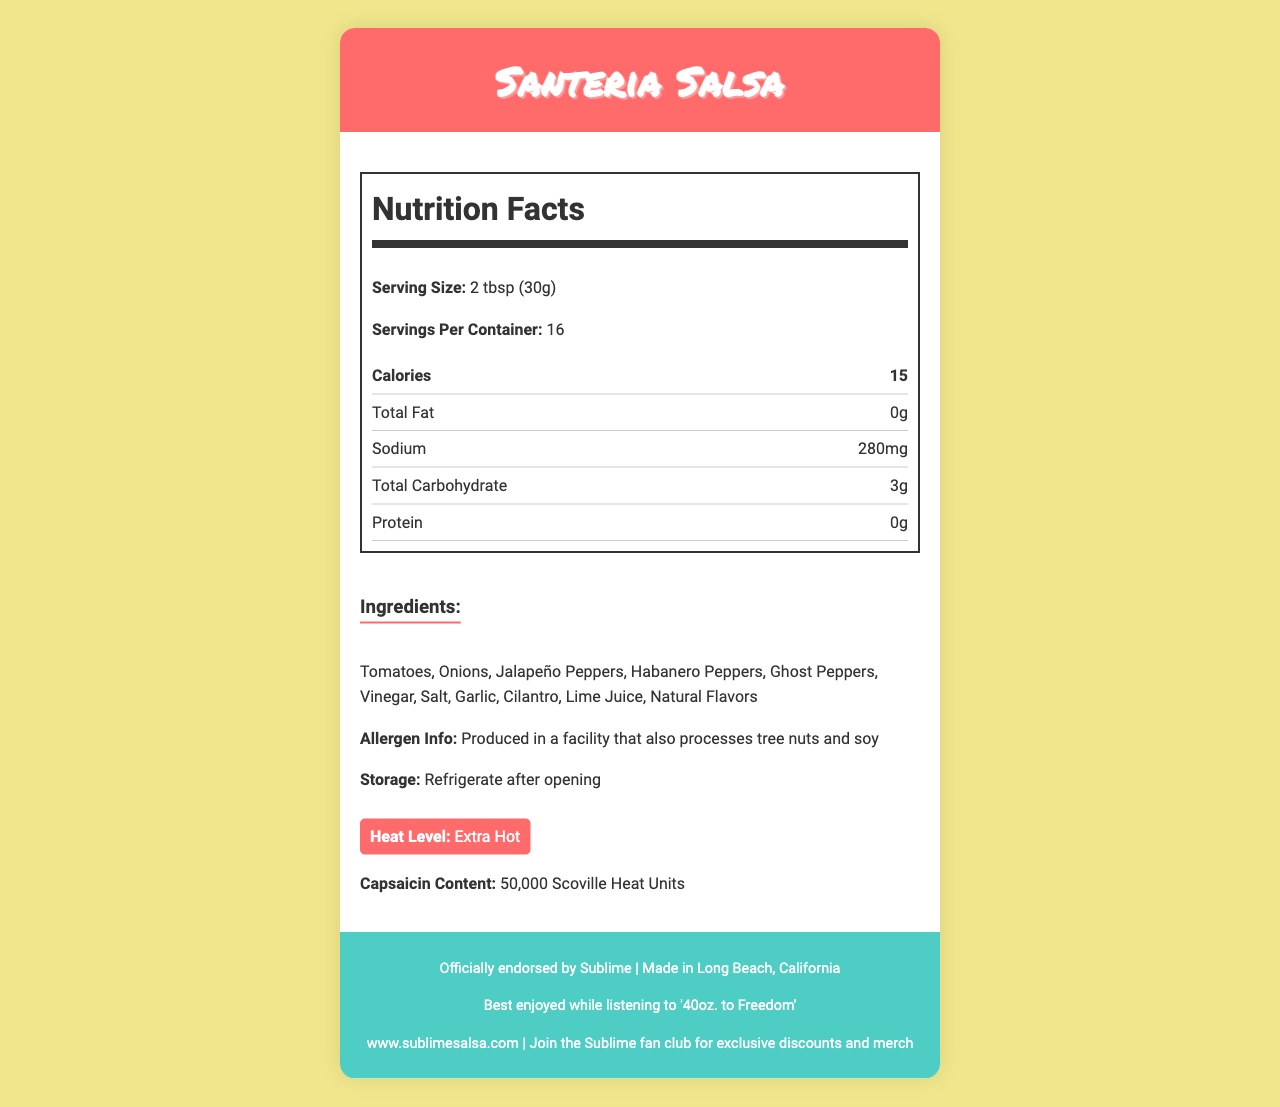what is the serving size? The serving size is stated in the "Nutrition Facts" section as "2 tbsp (30g)."
Answer: 2 tbsp (30g) how many servings are in one container? The document specifies "Servings Per Container" as "16" in the "Nutrition Facts" section.
Answer: 16 how many calories are in each serving? The "Nutrition Facts" section lists "Calories" as "15."
Answer: 15 what is the sodium content per serving? The sodium content per serving is listed as "280mg" in the "Nutrition Facts" section.
Answer: 280mg name three main ingredients in Santeria Salsa The ingredients list includes "Tomatoes," "Onions," "Jalapeño Peppers," among others.
Answer: Tomatoes, Onions, Jalapeño Peppers what is the capsaicin content in Scoville Heat Units? The document specifies "Capsaicin Content" as "50,000 Scoville Heat Units."
Answer: 50,000 Scoville Heat Units does this product contain any added sugars? The "Nutrition Facts" section shows "Added Sugars: 0g," implying no added sugars.
Answer: No which vitamin is present at the highest percentage of daily value? A. Vitamin A B. Vitamin C C. Calcium D. Iron The "Nutrition Facts" section shows "Vitamin C: 10%," which is the highest compared to the other listed vitamins and minerals.
Answer: B. Vitamin C what kind of peppers are included in the ingredients? A. Ghost Peppers B. Habanero Peppers C. Jalapeño Peppers D. All of the above The ingredients list includes "Ghost Peppers," "Habanero Peppers," and "Jalapeño Peppers."
Answer: D. All of the above is this product produced in a facility that processes tree nuts and soy? The "Allergen Info" section states, "Produced in a facility that also processes tree nuts and soy."
Answer: Yes what are the storage instructions for this product? The storage instructions in the document state "Refrigerate after opening."
Answer: Refrigerate after opening where is this salsa made? The “Origin” section mentions "Made in Long Beach, California."
Answer: Long Beach, California what is the recommended music pairing for enjoying this salsa? The document states "Best enjoyed while listening to '40oz. to Freedom'" in the footer section.
Answer: '40oz. to Freedom' what is the heat level of Santeria Salsa? The document contains a "Heat Level" section which states “Extra Hot.”
Answer: Extra Hot can this salsa be stored indefinitely? The "Shelf Life" section indicates "Best if used within 6 months of opening," so it cannot be stored indefinitely.
Answer: No who officially endorses Santeria Salsa? The footer states "Officially endorsed by Sublime."
Answer: Sublime is this product high in total fat? A. Yes B. No C. Cannot be determined D. I don’t know The "Nutrition Facts" section shows "Total Fat: 0g," indicating it is not high in total fat.
Answer: B. No is the packaging eco-friendly? The document states "Packaging made from 100% recycled materials," indicating eco-friendly packaging.
Answer: Yes what percentage of daily value does the Vitamin A content provide? The "Nutrition Facts" section lists "Vitamin A: 2%."
Answer: 2% when should this product be refrigerated? The storage instructions specify "Refrigerate after opening."
Answer: After opening summarize the main idea of the Santeria Salsa nutrition label document. This summary highlights the key nutritional facts, the association with Sublime, ingredient information, capsaicin content, storage instructions, and the eco-friendly nature of the packaging.
Answer: Santeria Salsa is a spicy condiment with an "Extra Hot" heat level, endorsed by the band Sublime, and made in Long Beach, California. The salsa contains no fat, cholesterol, or added sugars and has a notable sodium content. It features a blend of tomatoes, onions, and various peppers, including Ghost Peppers and Habanero Peppers, with a capsaicin content of 50,000 Scoville Heat Units. The packaging is eco-friendly, and the salsa offers Vitamin A and C. Storage instructions advise refrigerating after opening, and its shelf life is best within six months. The document emphasizes its connection to the band's culture and promotes the salsa as best enjoyed with their music. what are the health benefits of capsaicin? The document mentions the capsaicin content but does not provide details on its health benefits.
Answer: Not enough information 